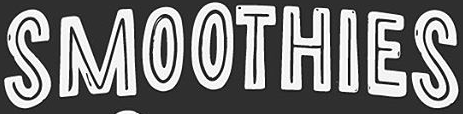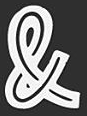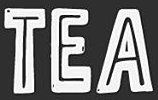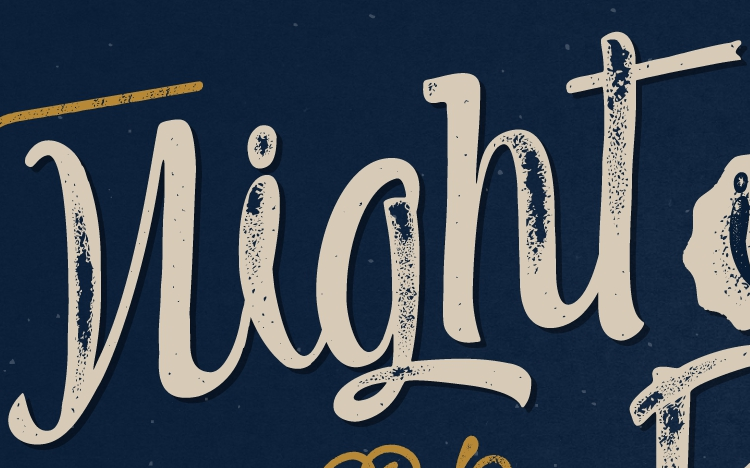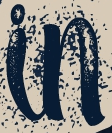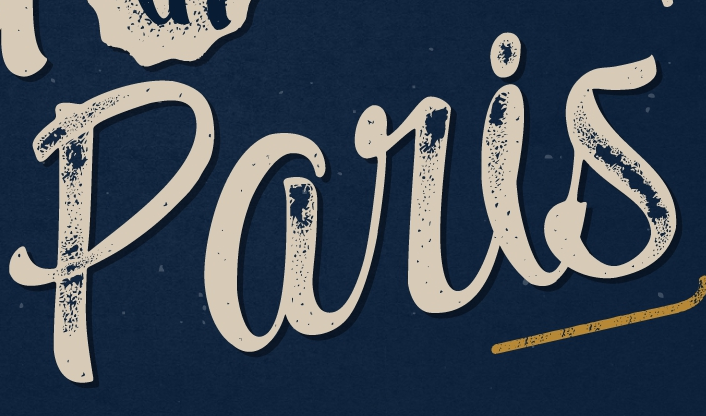Read the text content from these images in order, separated by a semicolon. SMOOTHIES; &; TEA; night; in; paris 